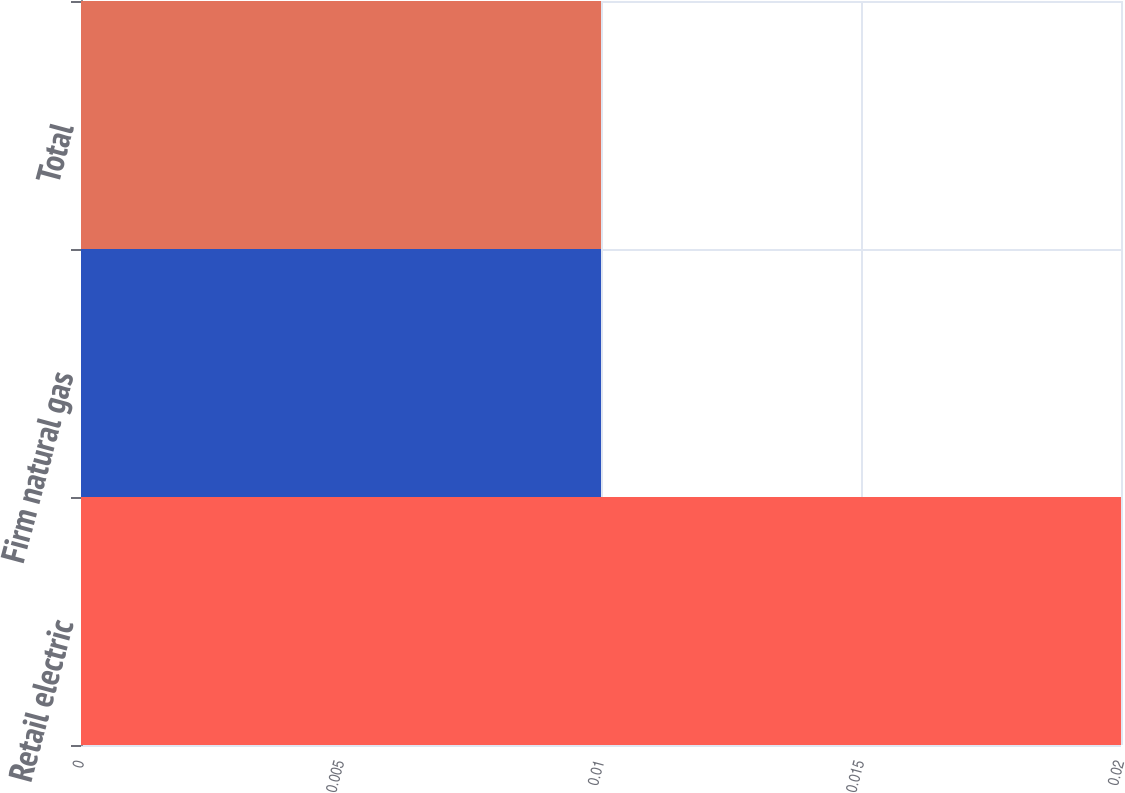Convert chart to OTSL. <chart><loc_0><loc_0><loc_500><loc_500><bar_chart><fcel>Retail electric<fcel>Firm natural gas<fcel>Total<nl><fcel>0.02<fcel>0.01<fcel>0.01<nl></chart> 